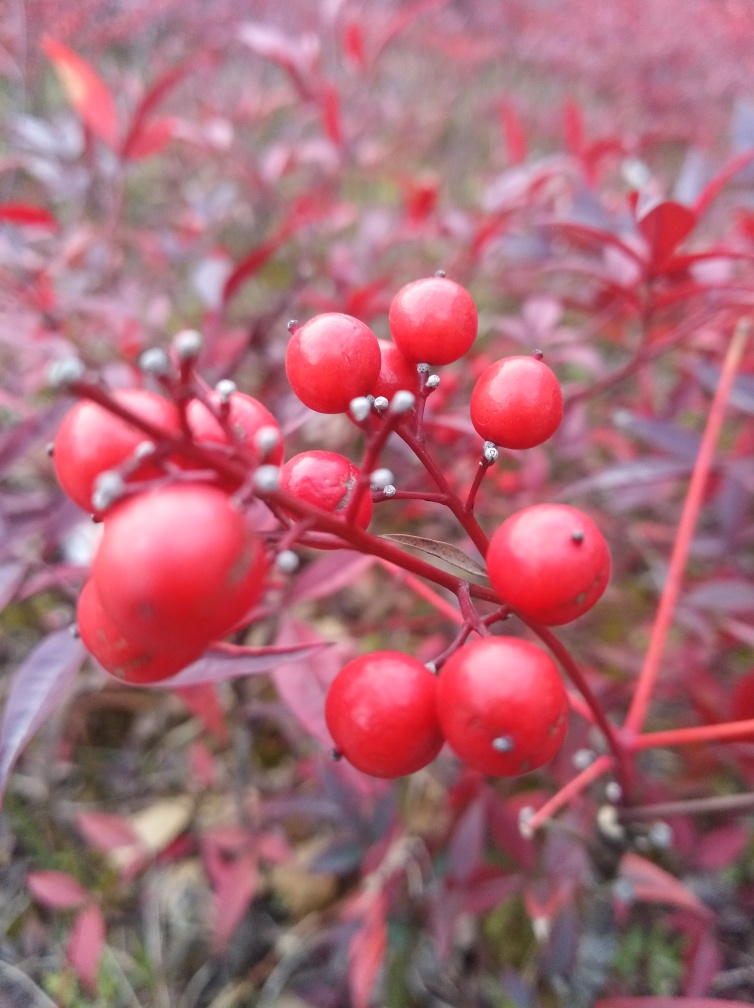Could this plant be found in a garden or wild setting? Based on the image, it's difficult to ascertain if the plant is part of a landscaped garden or grows in the wild. However, its natural and somewhat untended appearance could imply that it's growing in its natural habitat. 